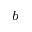<formula> <loc_0><loc_0><loc_500><loc_500>^ { b }</formula> 